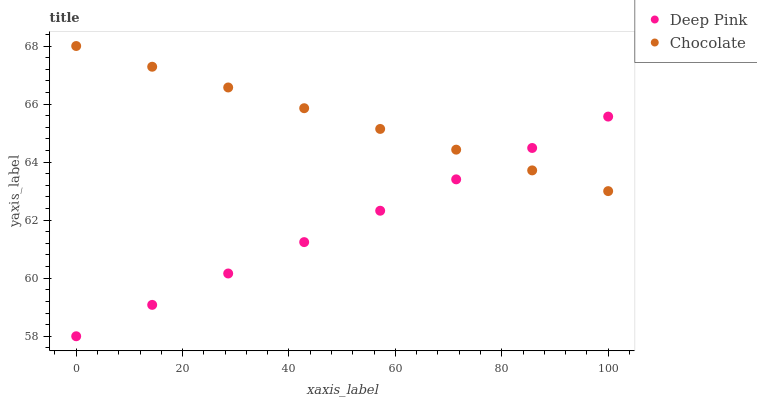Does Deep Pink have the minimum area under the curve?
Answer yes or no. Yes. Does Chocolate have the maximum area under the curve?
Answer yes or no. Yes. Does Chocolate have the minimum area under the curve?
Answer yes or no. No. Is Deep Pink the smoothest?
Answer yes or no. Yes. Is Chocolate the roughest?
Answer yes or no. Yes. Is Chocolate the smoothest?
Answer yes or no. No. Does Deep Pink have the lowest value?
Answer yes or no. Yes. Does Chocolate have the lowest value?
Answer yes or no. No. Does Chocolate have the highest value?
Answer yes or no. Yes. Does Deep Pink intersect Chocolate?
Answer yes or no. Yes. Is Deep Pink less than Chocolate?
Answer yes or no. No. Is Deep Pink greater than Chocolate?
Answer yes or no. No. 